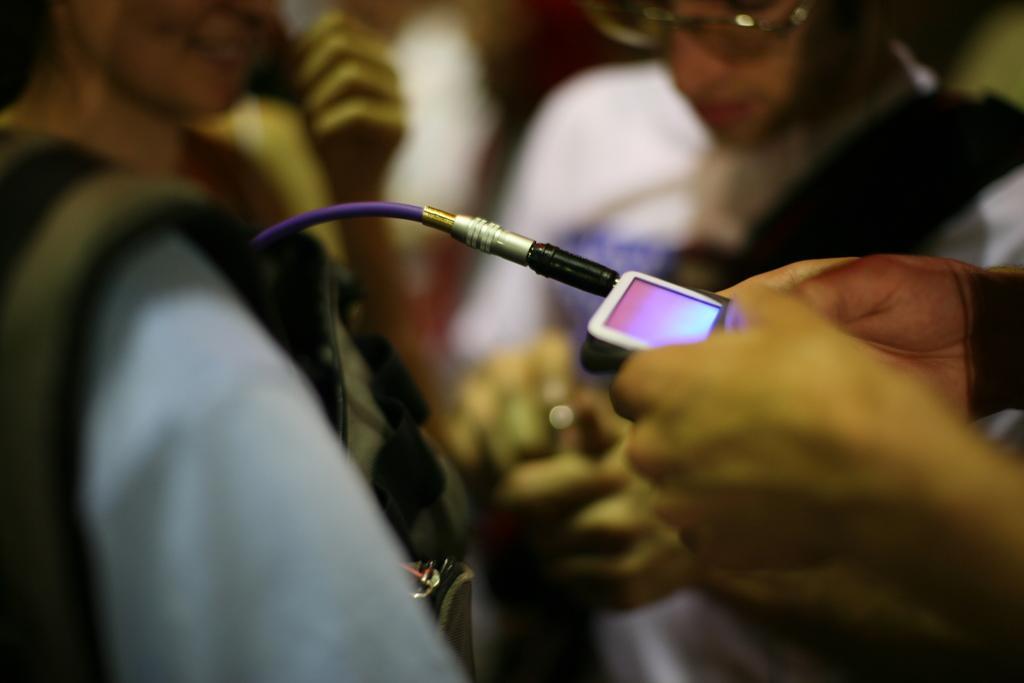Describe this image in one or two sentences. In this picture we can see hands of a person holding a device and there is a cable. There is a blur background and we can see two people. 